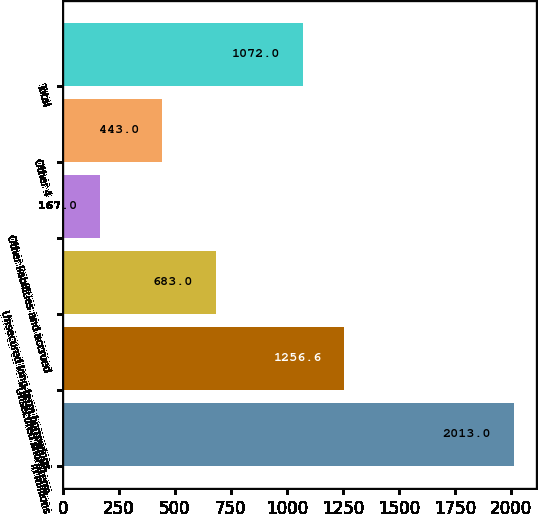Convert chart. <chart><loc_0><loc_0><loc_500><loc_500><bar_chart><fcel>in millions<fcel>Unsecured short-term<fcel>Unsecured long-term borrowings<fcel>Other liabilities and accrued<fcel>Other 4<fcel>Total<nl><fcel>2013<fcel>1256.6<fcel>683<fcel>167<fcel>443<fcel>1072<nl></chart> 